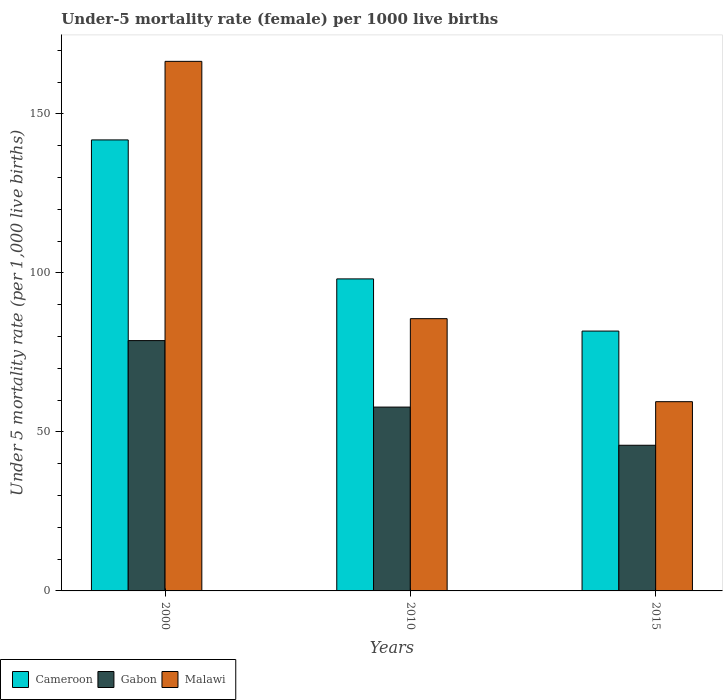How many different coloured bars are there?
Your response must be concise. 3. How many groups of bars are there?
Give a very brief answer. 3. Are the number of bars per tick equal to the number of legend labels?
Offer a terse response. Yes. Are the number of bars on each tick of the X-axis equal?
Your answer should be compact. Yes. How many bars are there on the 2nd tick from the left?
Offer a very short reply. 3. How many bars are there on the 3rd tick from the right?
Your answer should be very brief. 3. What is the label of the 1st group of bars from the left?
Provide a short and direct response. 2000. In how many cases, is the number of bars for a given year not equal to the number of legend labels?
Keep it short and to the point. 0. What is the under-five mortality rate in Gabon in 2000?
Your response must be concise. 78.7. Across all years, what is the maximum under-five mortality rate in Cameroon?
Provide a succinct answer. 141.8. Across all years, what is the minimum under-five mortality rate in Gabon?
Give a very brief answer. 45.8. In which year was the under-five mortality rate in Cameroon maximum?
Your response must be concise. 2000. In which year was the under-five mortality rate in Gabon minimum?
Provide a short and direct response. 2015. What is the total under-five mortality rate in Cameroon in the graph?
Provide a succinct answer. 321.6. What is the difference between the under-five mortality rate in Cameroon in 2010 and that in 2015?
Provide a short and direct response. 16.4. What is the difference between the under-five mortality rate in Cameroon in 2010 and the under-five mortality rate in Malawi in 2015?
Offer a terse response. 38.6. What is the average under-five mortality rate in Cameroon per year?
Your response must be concise. 107.2. In the year 2000, what is the difference between the under-five mortality rate in Cameroon and under-five mortality rate in Malawi?
Your answer should be very brief. -24.7. In how many years, is the under-five mortality rate in Cameroon greater than 80?
Offer a terse response. 3. What is the ratio of the under-five mortality rate in Gabon in 2000 to that in 2015?
Offer a terse response. 1.72. Is the under-five mortality rate in Malawi in 2000 less than that in 2015?
Ensure brevity in your answer.  No. What is the difference between the highest and the second highest under-five mortality rate in Gabon?
Offer a very short reply. 20.9. What is the difference between the highest and the lowest under-five mortality rate in Cameroon?
Keep it short and to the point. 60.1. In how many years, is the under-five mortality rate in Malawi greater than the average under-five mortality rate in Malawi taken over all years?
Give a very brief answer. 1. What does the 2nd bar from the left in 2015 represents?
Your answer should be very brief. Gabon. What does the 3rd bar from the right in 2015 represents?
Your answer should be compact. Cameroon. How many years are there in the graph?
Keep it short and to the point. 3. What is the difference between two consecutive major ticks on the Y-axis?
Give a very brief answer. 50. Does the graph contain any zero values?
Make the answer very short. No. How are the legend labels stacked?
Your answer should be compact. Horizontal. What is the title of the graph?
Ensure brevity in your answer.  Under-5 mortality rate (female) per 1000 live births. Does "Kenya" appear as one of the legend labels in the graph?
Your answer should be very brief. No. What is the label or title of the Y-axis?
Offer a terse response. Under 5 mortality rate (per 1,0 live births). What is the Under 5 mortality rate (per 1,000 live births) in Cameroon in 2000?
Provide a succinct answer. 141.8. What is the Under 5 mortality rate (per 1,000 live births) in Gabon in 2000?
Provide a succinct answer. 78.7. What is the Under 5 mortality rate (per 1,000 live births) in Malawi in 2000?
Offer a very short reply. 166.5. What is the Under 5 mortality rate (per 1,000 live births) of Cameroon in 2010?
Your answer should be compact. 98.1. What is the Under 5 mortality rate (per 1,000 live births) of Gabon in 2010?
Offer a very short reply. 57.8. What is the Under 5 mortality rate (per 1,000 live births) in Malawi in 2010?
Give a very brief answer. 85.6. What is the Under 5 mortality rate (per 1,000 live births) in Cameroon in 2015?
Provide a short and direct response. 81.7. What is the Under 5 mortality rate (per 1,000 live births) of Gabon in 2015?
Keep it short and to the point. 45.8. What is the Under 5 mortality rate (per 1,000 live births) of Malawi in 2015?
Offer a very short reply. 59.5. Across all years, what is the maximum Under 5 mortality rate (per 1,000 live births) of Cameroon?
Make the answer very short. 141.8. Across all years, what is the maximum Under 5 mortality rate (per 1,000 live births) in Gabon?
Ensure brevity in your answer.  78.7. Across all years, what is the maximum Under 5 mortality rate (per 1,000 live births) of Malawi?
Provide a succinct answer. 166.5. Across all years, what is the minimum Under 5 mortality rate (per 1,000 live births) in Cameroon?
Your answer should be very brief. 81.7. Across all years, what is the minimum Under 5 mortality rate (per 1,000 live births) in Gabon?
Keep it short and to the point. 45.8. Across all years, what is the minimum Under 5 mortality rate (per 1,000 live births) in Malawi?
Offer a terse response. 59.5. What is the total Under 5 mortality rate (per 1,000 live births) in Cameroon in the graph?
Provide a short and direct response. 321.6. What is the total Under 5 mortality rate (per 1,000 live births) in Gabon in the graph?
Offer a terse response. 182.3. What is the total Under 5 mortality rate (per 1,000 live births) of Malawi in the graph?
Offer a very short reply. 311.6. What is the difference between the Under 5 mortality rate (per 1,000 live births) of Cameroon in 2000 and that in 2010?
Offer a terse response. 43.7. What is the difference between the Under 5 mortality rate (per 1,000 live births) in Gabon in 2000 and that in 2010?
Give a very brief answer. 20.9. What is the difference between the Under 5 mortality rate (per 1,000 live births) of Malawi in 2000 and that in 2010?
Your response must be concise. 80.9. What is the difference between the Under 5 mortality rate (per 1,000 live births) in Cameroon in 2000 and that in 2015?
Your response must be concise. 60.1. What is the difference between the Under 5 mortality rate (per 1,000 live births) of Gabon in 2000 and that in 2015?
Keep it short and to the point. 32.9. What is the difference between the Under 5 mortality rate (per 1,000 live births) in Malawi in 2000 and that in 2015?
Your response must be concise. 107. What is the difference between the Under 5 mortality rate (per 1,000 live births) in Malawi in 2010 and that in 2015?
Keep it short and to the point. 26.1. What is the difference between the Under 5 mortality rate (per 1,000 live births) in Cameroon in 2000 and the Under 5 mortality rate (per 1,000 live births) in Malawi in 2010?
Offer a very short reply. 56.2. What is the difference between the Under 5 mortality rate (per 1,000 live births) of Gabon in 2000 and the Under 5 mortality rate (per 1,000 live births) of Malawi in 2010?
Offer a terse response. -6.9. What is the difference between the Under 5 mortality rate (per 1,000 live births) of Cameroon in 2000 and the Under 5 mortality rate (per 1,000 live births) of Gabon in 2015?
Offer a terse response. 96. What is the difference between the Under 5 mortality rate (per 1,000 live births) of Cameroon in 2000 and the Under 5 mortality rate (per 1,000 live births) of Malawi in 2015?
Your answer should be compact. 82.3. What is the difference between the Under 5 mortality rate (per 1,000 live births) in Cameroon in 2010 and the Under 5 mortality rate (per 1,000 live births) in Gabon in 2015?
Provide a succinct answer. 52.3. What is the difference between the Under 5 mortality rate (per 1,000 live births) in Cameroon in 2010 and the Under 5 mortality rate (per 1,000 live births) in Malawi in 2015?
Make the answer very short. 38.6. What is the average Under 5 mortality rate (per 1,000 live births) in Cameroon per year?
Offer a very short reply. 107.2. What is the average Under 5 mortality rate (per 1,000 live births) of Gabon per year?
Ensure brevity in your answer.  60.77. What is the average Under 5 mortality rate (per 1,000 live births) of Malawi per year?
Give a very brief answer. 103.87. In the year 2000, what is the difference between the Under 5 mortality rate (per 1,000 live births) of Cameroon and Under 5 mortality rate (per 1,000 live births) of Gabon?
Make the answer very short. 63.1. In the year 2000, what is the difference between the Under 5 mortality rate (per 1,000 live births) of Cameroon and Under 5 mortality rate (per 1,000 live births) of Malawi?
Give a very brief answer. -24.7. In the year 2000, what is the difference between the Under 5 mortality rate (per 1,000 live births) in Gabon and Under 5 mortality rate (per 1,000 live births) in Malawi?
Keep it short and to the point. -87.8. In the year 2010, what is the difference between the Under 5 mortality rate (per 1,000 live births) in Cameroon and Under 5 mortality rate (per 1,000 live births) in Gabon?
Your response must be concise. 40.3. In the year 2010, what is the difference between the Under 5 mortality rate (per 1,000 live births) of Cameroon and Under 5 mortality rate (per 1,000 live births) of Malawi?
Make the answer very short. 12.5. In the year 2010, what is the difference between the Under 5 mortality rate (per 1,000 live births) in Gabon and Under 5 mortality rate (per 1,000 live births) in Malawi?
Offer a terse response. -27.8. In the year 2015, what is the difference between the Under 5 mortality rate (per 1,000 live births) of Cameroon and Under 5 mortality rate (per 1,000 live births) of Gabon?
Your response must be concise. 35.9. In the year 2015, what is the difference between the Under 5 mortality rate (per 1,000 live births) in Cameroon and Under 5 mortality rate (per 1,000 live births) in Malawi?
Provide a short and direct response. 22.2. In the year 2015, what is the difference between the Under 5 mortality rate (per 1,000 live births) in Gabon and Under 5 mortality rate (per 1,000 live births) in Malawi?
Make the answer very short. -13.7. What is the ratio of the Under 5 mortality rate (per 1,000 live births) in Cameroon in 2000 to that in 2010?
Give a very brief answer. 1.45. What is the ratio of the Under 5 mortality rate (per 1,000 live births) of Gabon in 2000 to that in 2010?
Offer a very short reply. 1.36. What is the ratio of the Under 5 mortality rate (per 1,000 live births) of Malawi in 2000 to that in 2010?
Make the answer very short. 1.95. What is the ratio of the Under 5 mortality rate (per 1,000 live births) of Cameroon in 2000 to that in 2015?
Your answer should be very brief. 1.74. What is the ratio of the Under 5 mortality rate (per 1,000 live births) of Gabon in 2000 to that in 2015?
Offer a very short reply. 1.72. What is the ratio of the Under 5 mortality rate (per 1,000 live births) in Malawi in 2000 to that in 2015?
Offer a very short reply. 2.8. What is the ratio of the Under 5 mortality rate (per 1,000 live births) of Cameroon in 2010 to that in 2015?
Keep it short and to the point. 1.2. What is the ratio of the Under 5 mortality rate (per 1,000 live births) in Gabon in 2010 to that in 2015?
Offer a very short reply. 1.26. What is the ratio of the Under 5 mortality rate (per 1,000 live births) of Malawi in 2010 to that in 2015?
Your answer should be very brief. 1.44. What is the difference between the highest and the second highest Under 5 mortality rate (per 1,000 live births) of Cameroon?
Offer a very short reply. 43.7. What is the difference between the highest and the second highest Under 5 mortality rate (per 1,000 live births) in Gabon?
Provide a succinct answer. 20.9. What is the difference between the highest and the second highest Under 5 mortality rate (per 1,000 live births) of Malawi?
Your answer should be compact. 80.9. What is the difference between the highest and the lowest Under 5 mortality rate (per 1,000 live births) of Cameroon?
Provide a short and direct response. 60.1. What is the difference between the highest and the lowest Under 5 mortality rate (per 1,000 live births) in Gabon?
Ensure brevity in your answer.  32.9. What is the difference between the highest and the lowest Under 5 mortality rate (per 1,000 live births) in Malawi?
Your response must be concise. 107. 